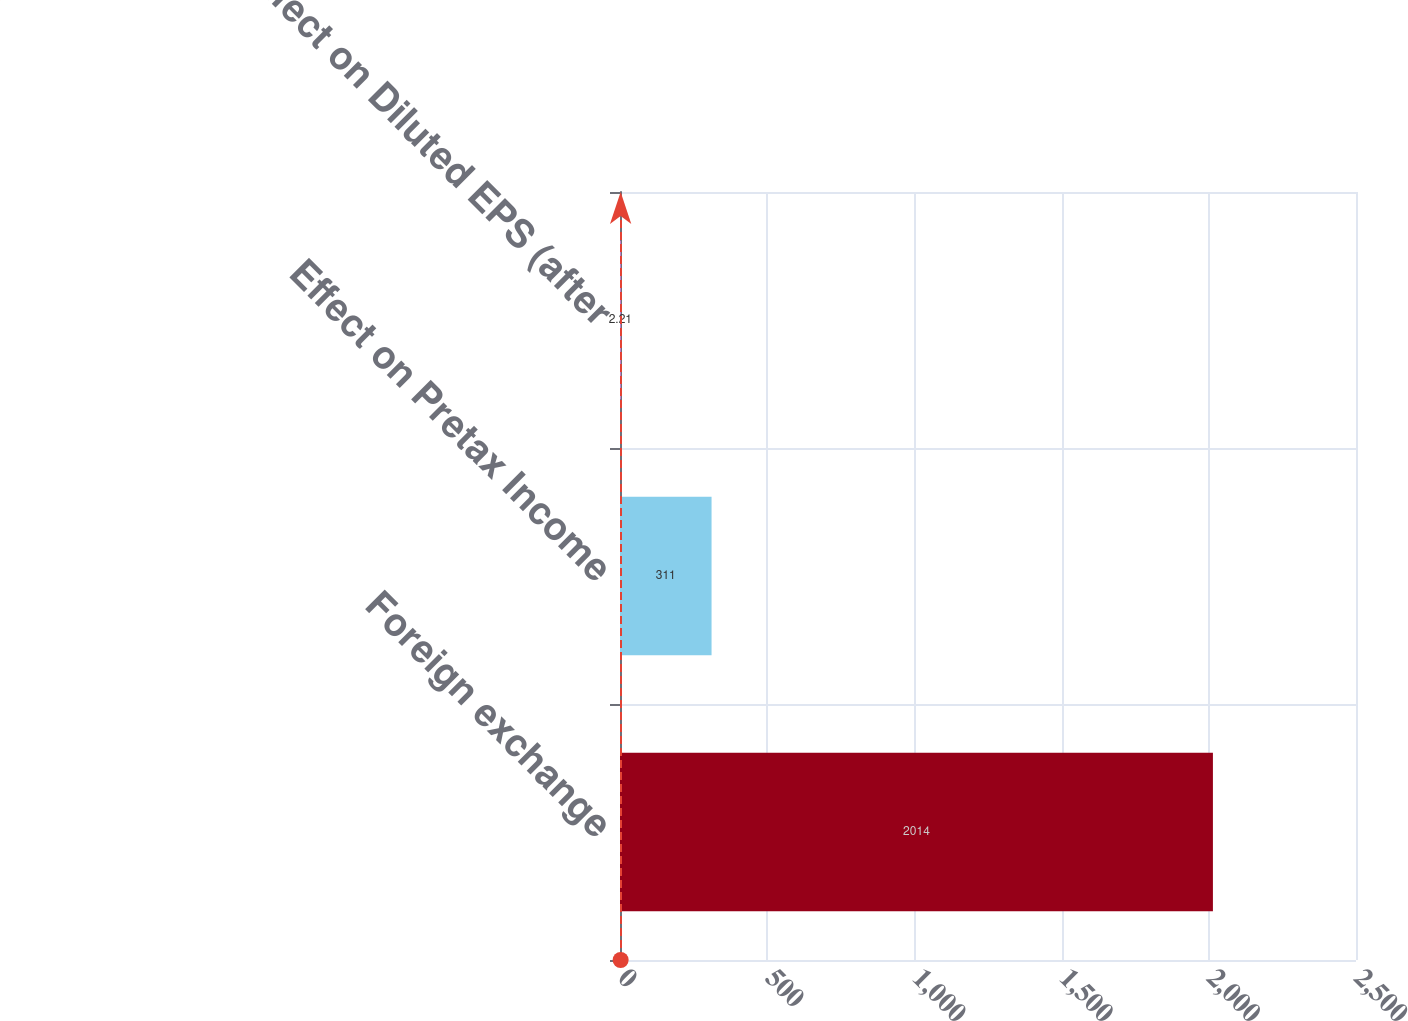Convert chart. <chart><loc_0><loc_0><loc_500><loc_500><bar_chart><fcel>Foreign exchange<fcel>Effect on Pretax Income<fcel>Effect on Diluted EPS (after<nl><fcel>2014<fcel>311<fcel>2.21<nl></chart> 